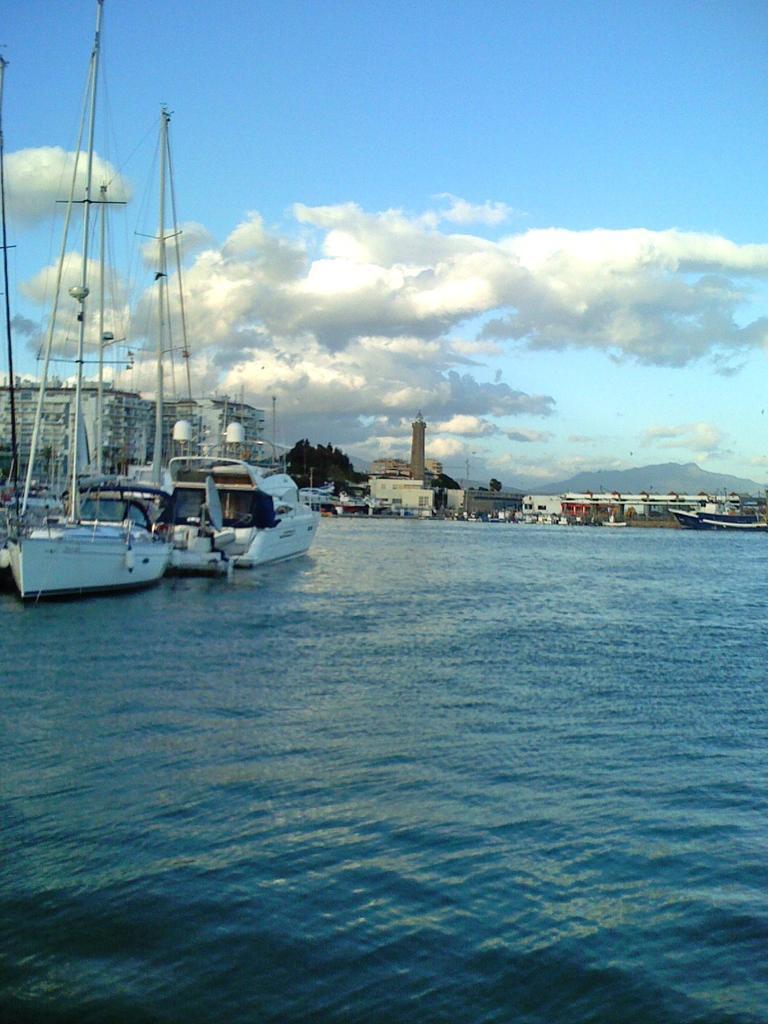Please provide a concise description of this image. In this image we can see some ships on the water and there are some buildings and trees in the background. We can see the mountains and at the top we can see the sky. 